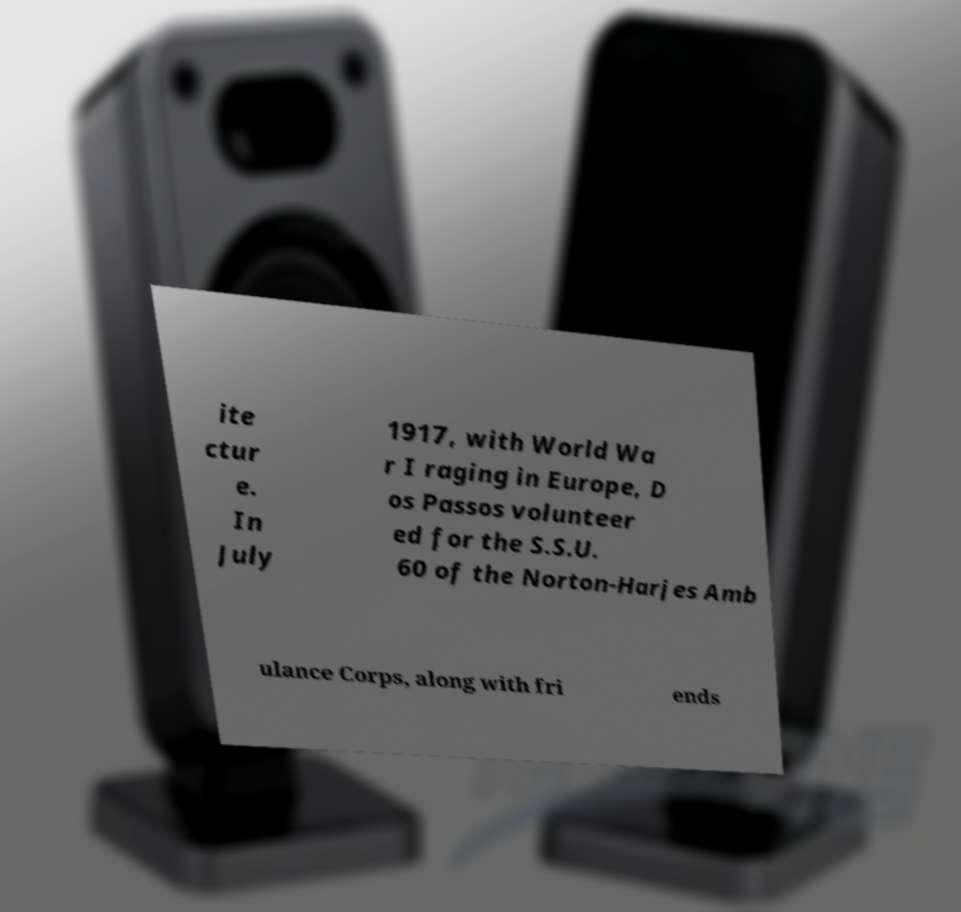Could you extract and type out the text from this image? ite ctur e. In July 1917, with World Wa r I raging in Europe, D os Passos volunteer ed for the S.S.U. 60 of the Norton-Harjes Amb ulance Corps, along with fri ends 